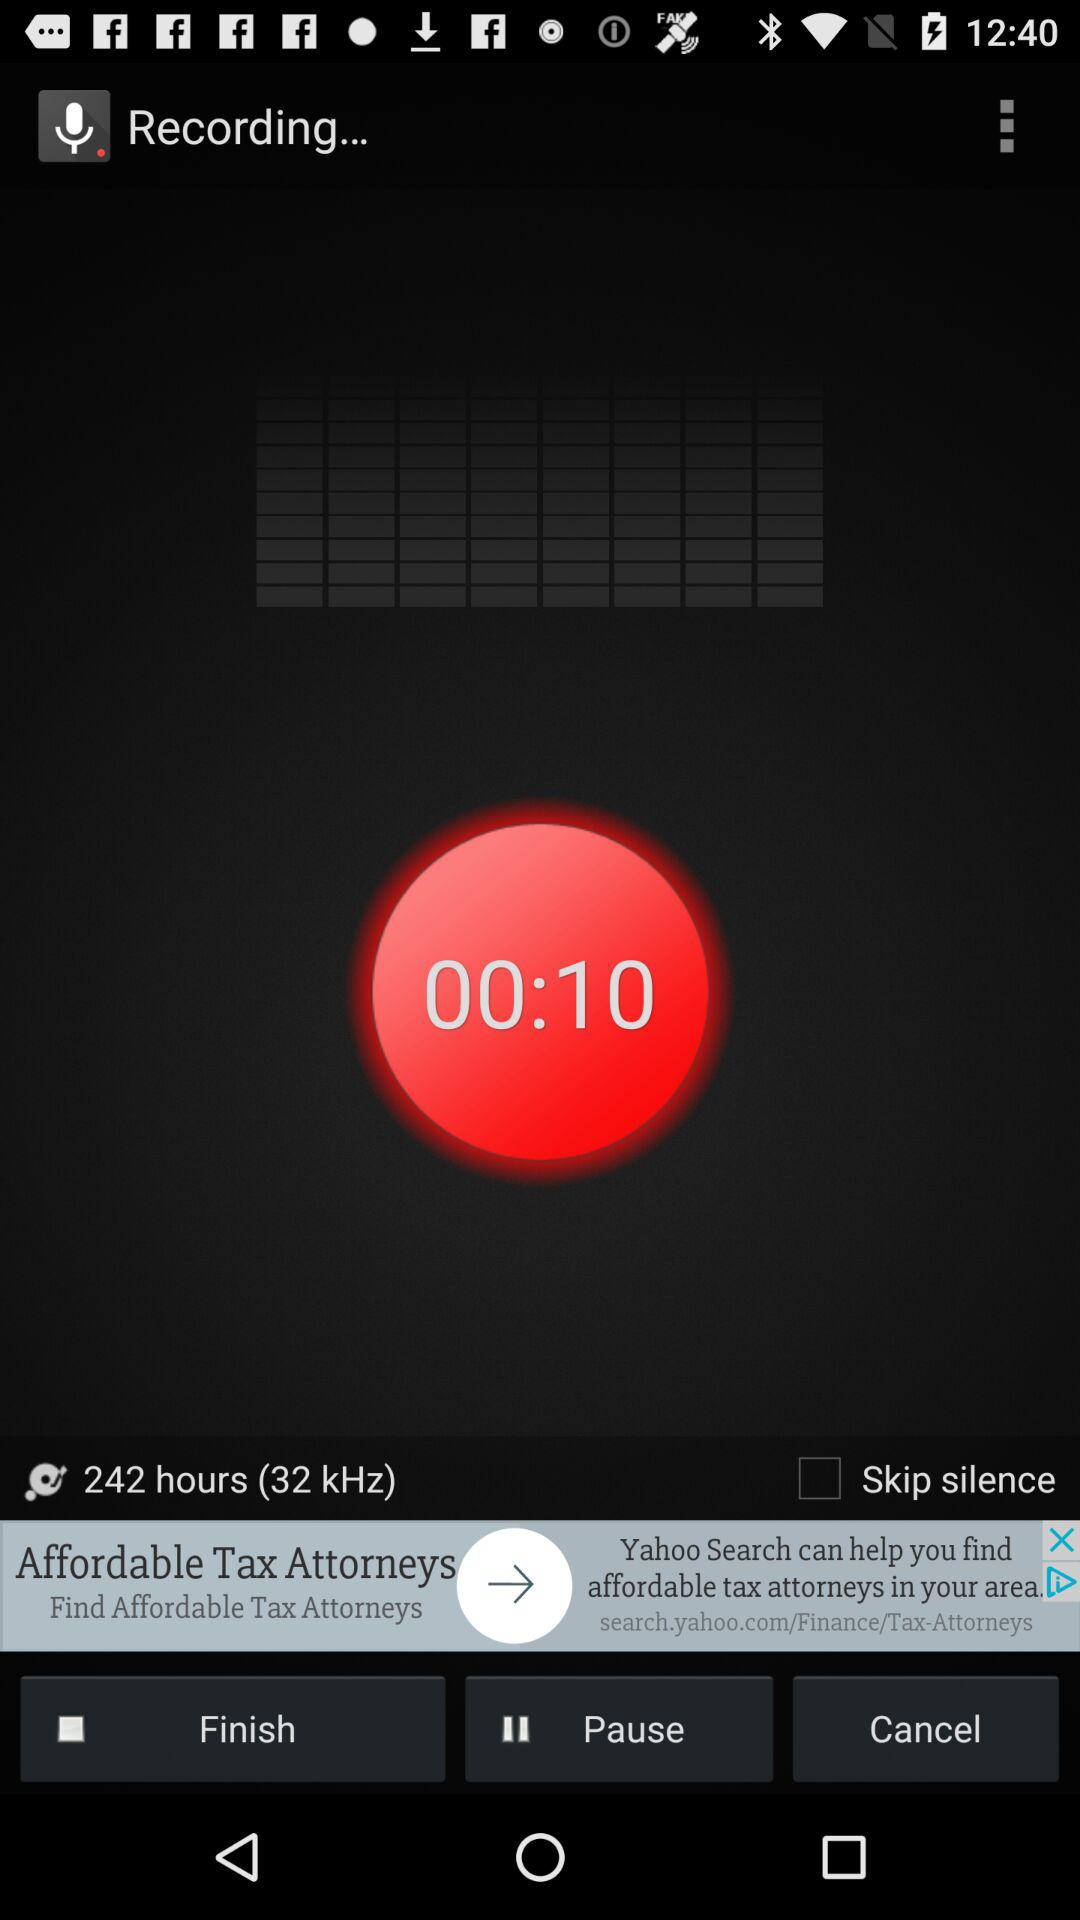How many hours of recording is available?
Answer the question using a single word or phrase. 242 